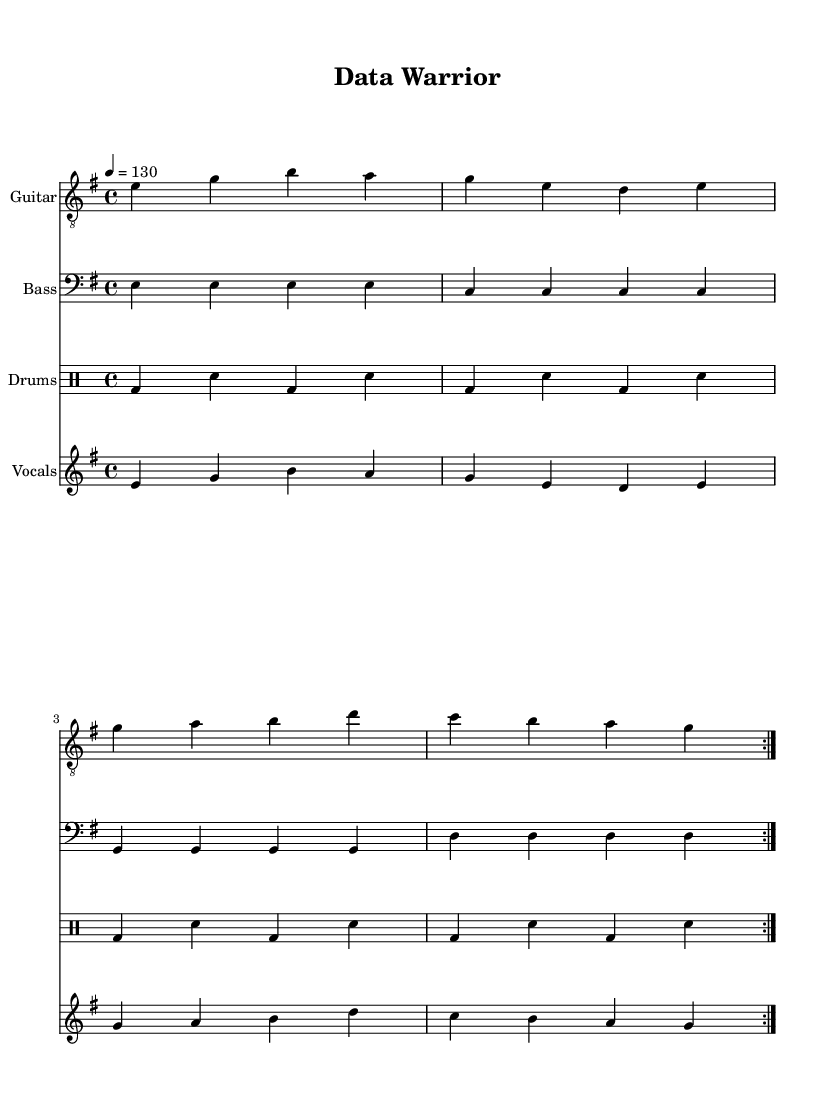What is the key signature of this music? The key signature shows that the piece is in E minor, which has one sharp. This can be identified at the beginning of the staff where the sharp is placed, indicating E minor.
Answer: E minor What is the time signature of this music? The time signature is found next to the key signature, which shows 4/4. This indicates that there are four beats in each measure and the quarter note gets the beat.
Answer: 4/4 What is the tempo marking of the music? The tempo marking is indicated with "4 = 130" at the beginning of the score. This means that a quarter note is played at a speed of 130 beats per minute.
Answer: 130 How many times is the guitar section repeated? The repeat indication “\repeat volta 2” means that the guitar section is played two times. This is common in songs to emphasize certain parts.
Answer: 2 What instrumental roles are present in this piece? The score includes a guitar, bass, drums, and vocals, as seen from the instruments listed in the staff labels. Each instrument has a distinct role in the arrangement.
Answer: Guitar, bass, drums, vocals What themes do the lyrics convey? The lyrics speak about overcoming challenges in data collection, expressing a struggle and determination in the face of adversity as a "Data Warrior." This theme relates directly to the title and subject matter.
Answer: Overcoming challenges What type of music is this? The presence of electric guitar riffs, strong bass lines, and a driving rhythm indicates that this piece falls within the hard rock genre, which typically features these elements.
Answer: Hard rock 